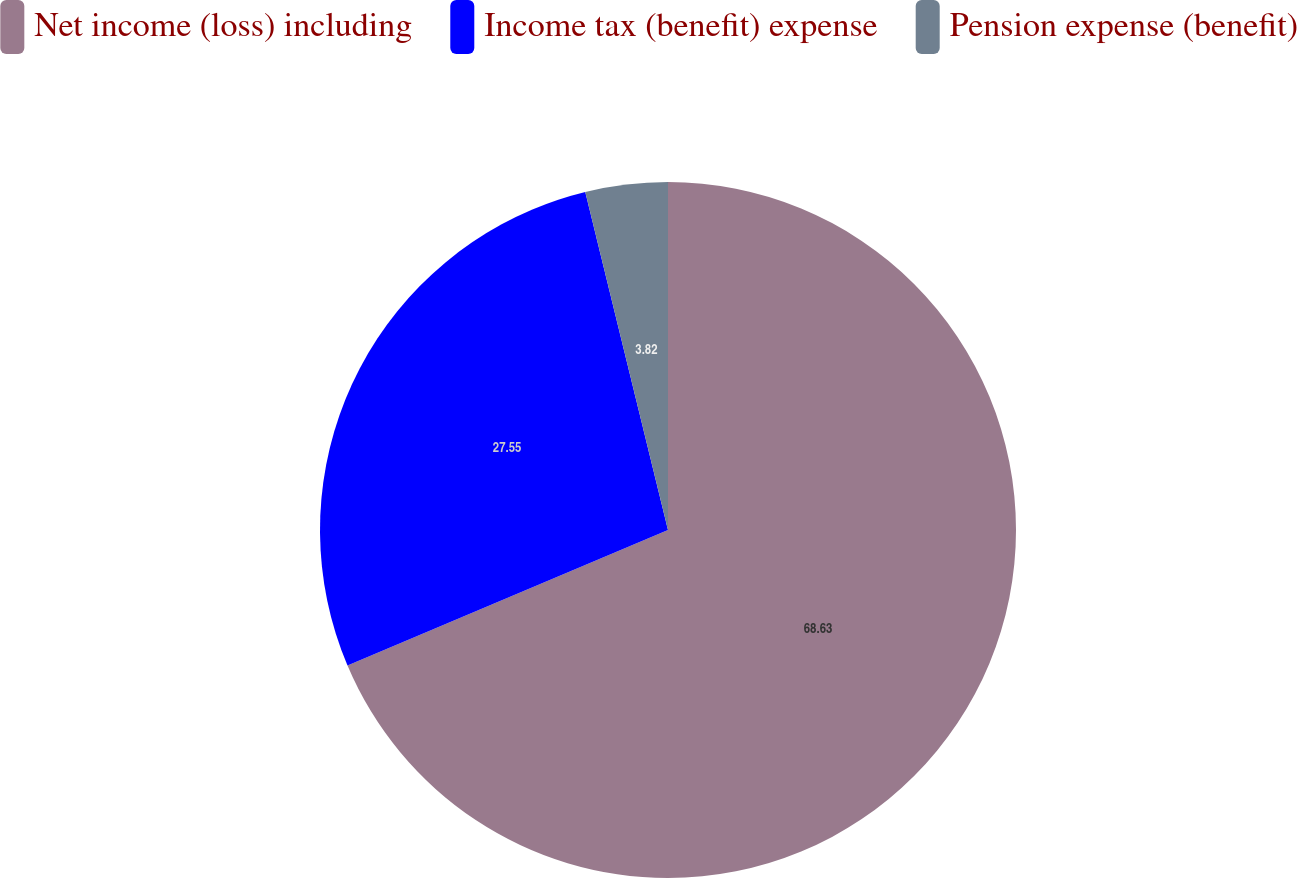<chart> <loc_0><loc_0><loc_500><loc_500><pie_chart><fcel>Net income (loss) including<fcel>Income tax (benefit) expense<fcel>Pension expense (benefit)<nl><fcel>68.63%<fcel>27.55%<fcel>3.82%<nl></chart> 